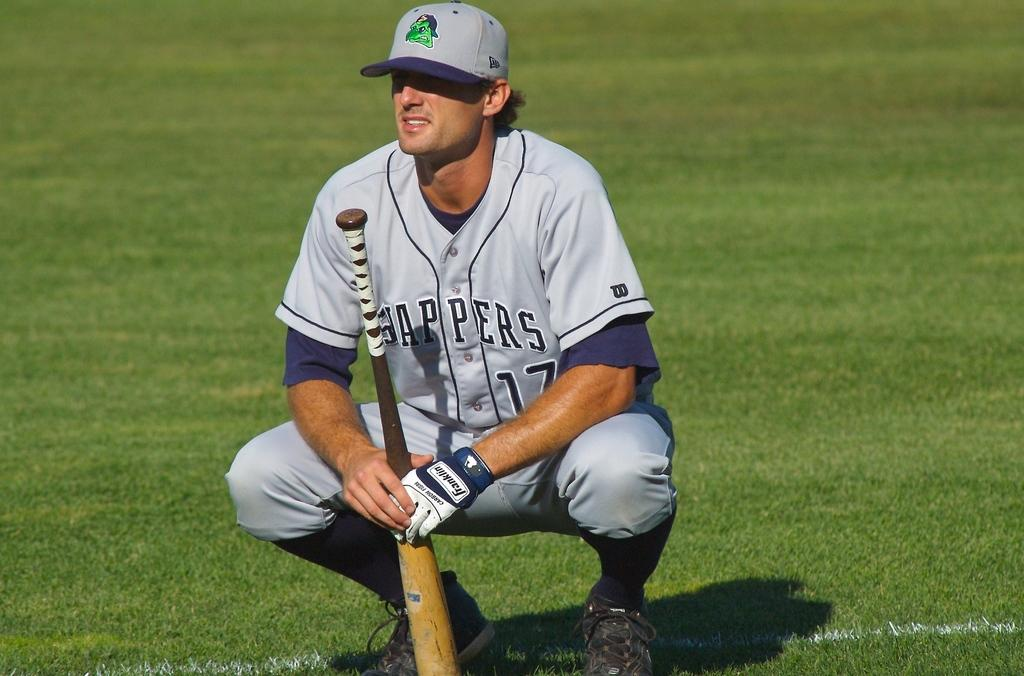<image>
Present a compact description of the photo's key features. A baseball player in a Sappers jersey squats down on the field while holding a baseball bat. 